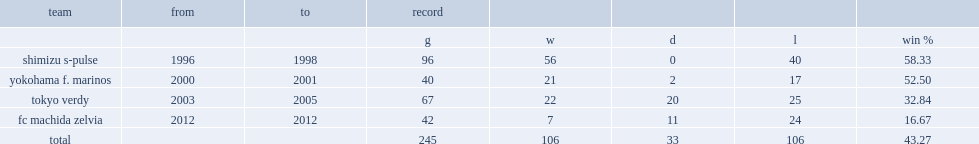When did osvaldo ardiles become the coach of yokohama f. marinos. 2000.0. 